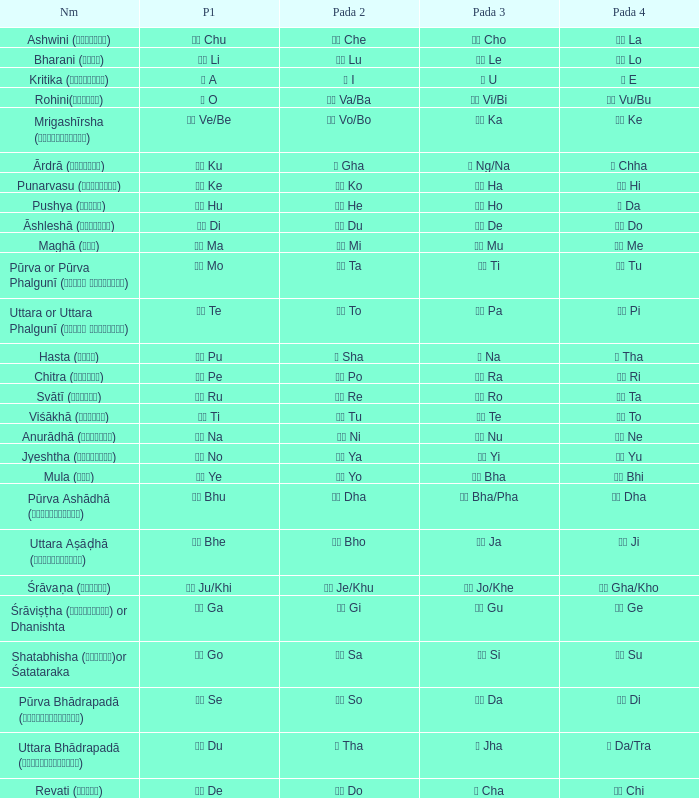What is the Name of ङ ng/na? Ārdrā (आर्द्रा). 